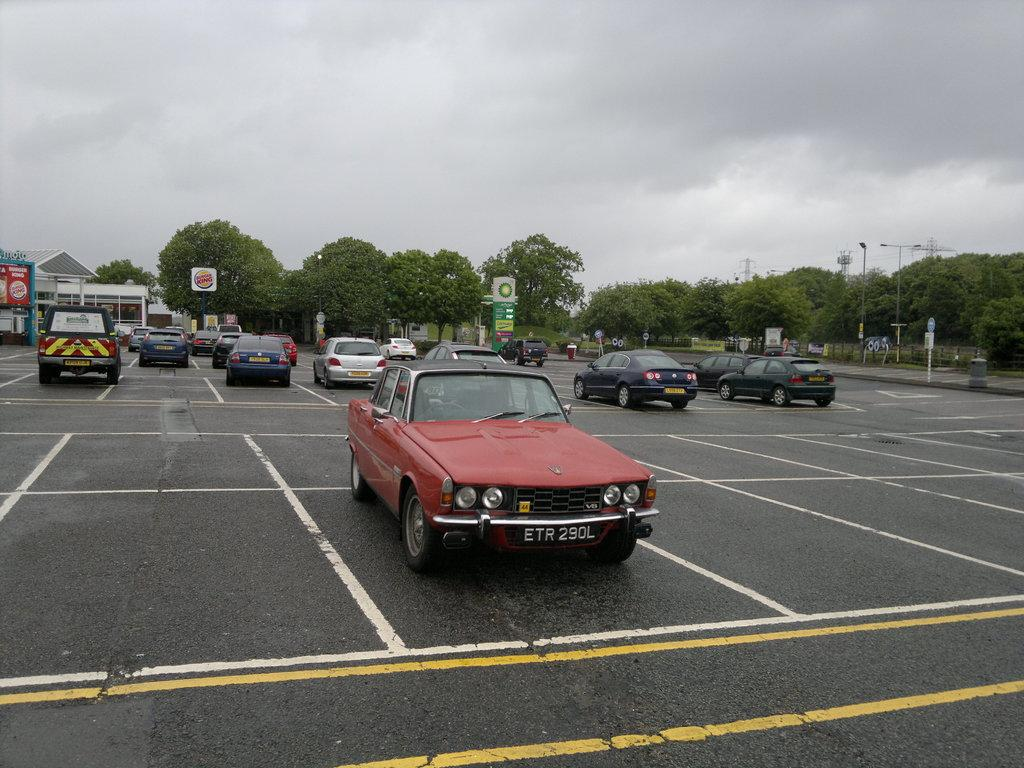What can be seen on the road in the image? There are cars on the road in the image. What is visible in the background of the image? Stores, trees, sign boards, and hoardings are present in the background of the image. What structures can be seen in the image? Poles and towers are present in the image. What type of holiday is being celebrated in the image? There is no indication of a holiday being celebrated in the image. What ingredients are used to make the stew in the image? There is no stew present in the image. 